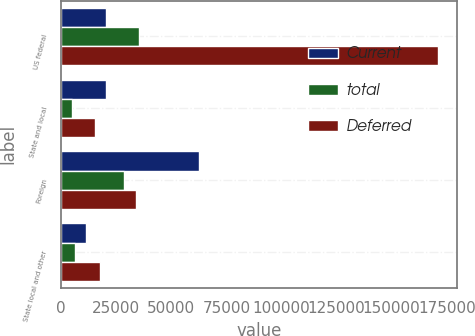Convert chart to OTSL. <chart><loc_0><loc_0><loc_500><loc_500><stacked_bar_chart><ecel><fcel>US federal<fcel>State and local<fcel>Foreign<fcel>State local and other<nl><fcel>Current<fcel>20320<fcel>20320<fcel>62322<fcel>11363<nl><fcel>total<fcel>35313<fcel>4932<fcel>28354<fcel>6288<nl><fcel>Deferred<fcel>171122<fcel>15388<fcel>33968<fcel>17651<nl></chart> 